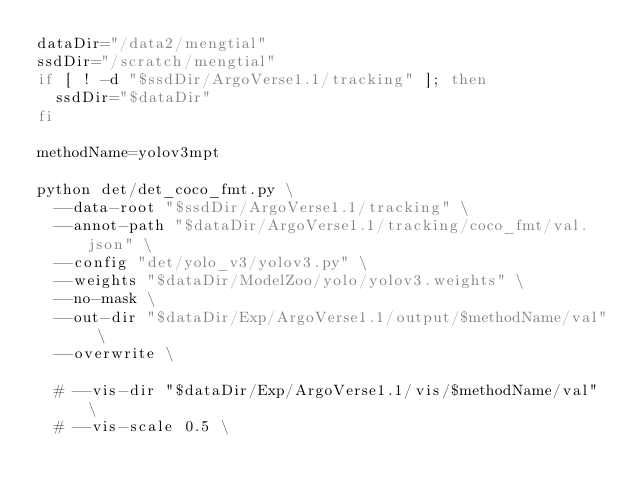<code> <loc_0><loc_0><loc_500><loc_500><_Bash_>dataDir="/data2/mengtial"
ssdDir="/scratch/mengtial"
if [ ! -d "$ssdDir/ArgoVerse1.1/tracking" ]; then
  ssdDir="$dataDir"
fi

methodName=yolov3mpt

python det/det_coco_fmt.py \
	--data-root "$ssdDir/ArgoVerse1.1/tracking" \
	--annot-path "$dataDir/ArgoVerse1.1/tracking/coco_fmt/val.json" \
	--config "det/yolo_v3/yolov3.py" \
	--weights "$dataDir/ModelZoo/yolo/yolov3.weights" \
	--no-mask \
	--out-dir "$dataDir/Exp/ArgoVerse1.1/output/$methodName/val" \
	--overwrite \

	# --vis-dir "$dataDir/Exp/ArgoVerse1.1/vis/$methodName/val" \
	# --vis-scale 0.5 \</code> 